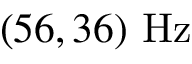<formula> <loc_0><loc_0><loc_500><loc_500>( 5 6 , 3 6 ) \ H z</formula> 